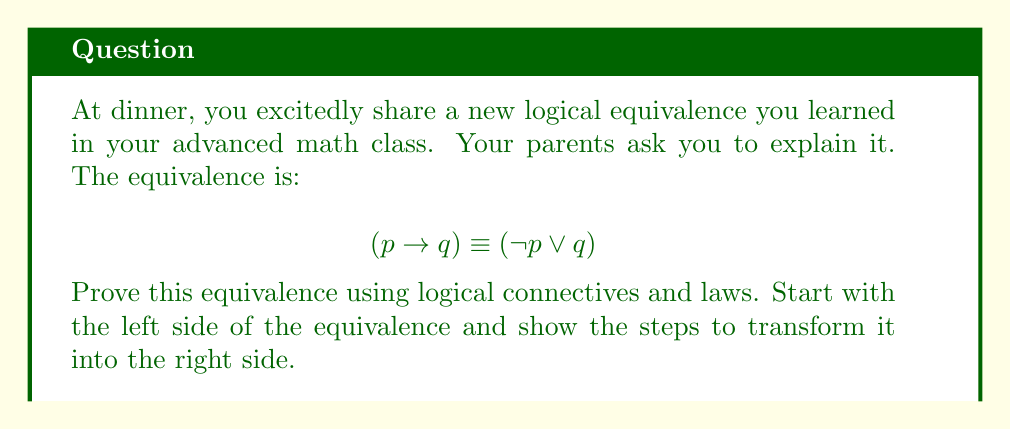What is the answer to this math problem? Let's prove the equivalence step by step:

1) Start with the left side of the equivalence: $(p \rightarrow q)$

2) By the definition of implication, we can rewrite this as:
   $$(p \rightarrow q) \equiv (\neg p \lor q)$$

   This is actually the equivalence we're trying to prove, but let's continue to show why this is true.

3) Let's consider the truth table for $(p \rightarrow q)$:

   | $p$ | $q$ | $(p \rightarrow q)$ |
   |-----|-----|---------------------|
   | T   | T   | T                   |
   | T   | F   | F                   |
   | F   | T   | T                   |
   | F   | F   | T                   |

4) Now, let's consider the truth table for $(\neg p \lor q)$:

   | $p$ | $q$ | $\neg p$ | $(\neg p \lor q)$ |
   |-----|-----|----------|-------------------|
   | T   | T   | F        | T                 |
   | T   | F   | F        | F                 |
   | F   | T   | T        | T                 |
   | F   | F   | T        | T                 |

5) We can see that the truth tables for $(p \rightarrow q)$ and $(\neg p \lor q)$ are identical, which proves their logical equivalence.

6) To further understand this, we can break down the implication:
   - $(p \rightarrow q)$ is false only when $p$ is true and $q$ is false.
   - In all other cases, it's true.

7) Similarly, $(\neg p \lor q)$ is false only when $p$ is true (so $\neg p$ is false) and $q$ is false.
   - In all other cases, at least one of $\neg p$ or $q$ is true, making the whole expression true.

This demonstrates why $(p \rightarrow q) \equiv (\neg p \lor q)$ is a valid logical equivalence.
Answer: The equivalence $(p \rightarrow q) \equiv (\neg p \lor q)$ is proven by showing that both expressions have identical truth tables, and by demonstrating that they are false only under the same condition (when $p$ is true and $q$ is false) and true in all other cases. 